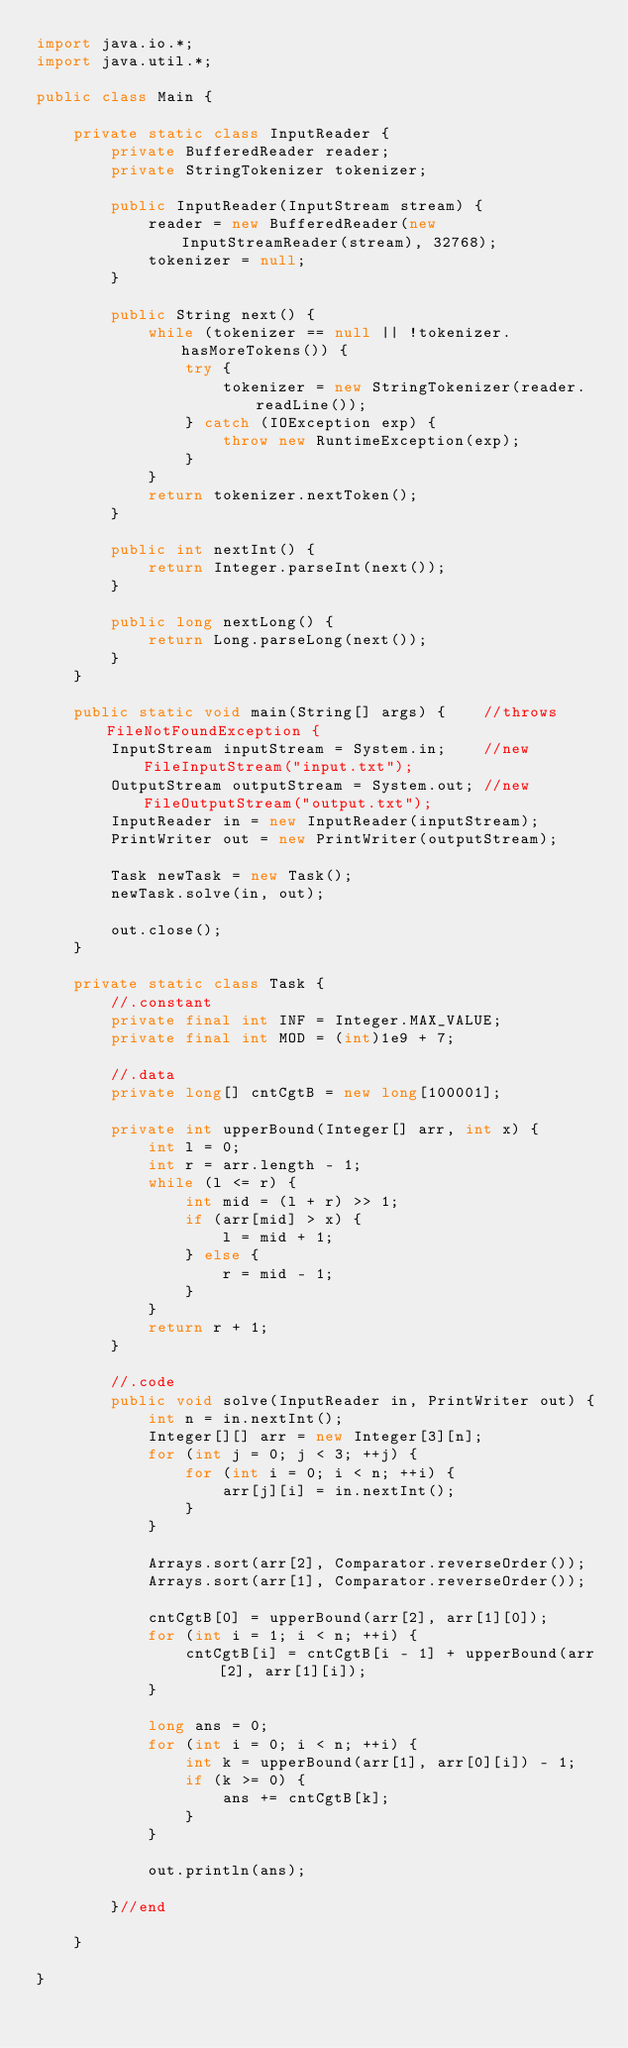Convert code to text. <code><loc_0><loc_0><loc_500><loc_500><_Java_>import java.io.*;
import java.util.*;

public class Main {

    private static class InputReader {
        private BufferedReader reader;
        private StringTokenizer tokenizer;

        public InputReader(InputStream stream) {
            reader = new BufferedReader(new InputStreamReader(stream), 32768);
            tokenizer = null;
        }

        public String next() {
            while (tokenizer == null || !tokenizer.hasMoreTokens()) {
                try {
                    tokenizer = new StringTokenizer(reader.readLine());
                } catch (IOException exp) {
                    throw new RuntimeException(exp);
                }
            }
            return tokenizer.nextToken();
        }

        public int nextInt() {
            return Integer.parseInt(next());
        }

        public long nextLong() {
            return Long.parseLong(next());
        }
    }

    public static void main(String[] args) {    //throws FileNotFoundException {
        InputStream inputStream = System.in;    //new FileInputStream("input.txt");
        OutputStream outputStream = System.out; //new FileOutputStream("output.txt");
        InputReader in = new InputReader(inputStream);
        PrintWriter out = new PrintWriter(outputStream);

        Task newTask = new Task();
        newTask.solve(in, out);

        out.close();
    }

    private static class Task {
        //.constant
        private final int INF = Integer.MAX_VALUE;
        private final int MOD = (int)1e9 + 7;

        //.data
        private long[] cntCgtB = new long[100001];

        private int upperBound(Integer[] arr, int x) {
            int l = 0;
            int r = arr.length - 1;
            while (l <= r) {
                int mid = (l + r) >> 1;
                if (arr[mid] > x) {
                    l = mid + 1;
                } else {
                    r = mid - 1;
                }
            }
            return r + 1;
        }

        //.code
        public void solve(InputReader in, PrintWriter out) {
            int n = in.nextInt();
            Integer[][] arr = new Integer[3][n];
            for (int j = 0; j < 3; ++j) {
                for (int i = 0; i < n; ++i) {
                    arr[j][i] = in.nextInt();
                }
            }

            Arrays.sort(arr[2], Comparator.reverseOrder());
            Arrays.sort(arr[1], Comparator.reverseOrder());

            cntCgtB[0] = upperBound(arr[2], arr[1][0]);
            for (int i = 1; i < n; ++i) {
                cntCgtB[i] = cntCgtB[i - 1] + upperBound(arr[2], arr[1][i]);
            }

            long ans = 0;
            for (int i = 0; i < n; ++i) {
                int k = upperBound(arr[1], arr[0][i]) - 1;
                if (k >= 0) {
                    ans += cntCgtB[k];
                }
            }

            out.println(ans);

        }//end

    }

}</code> 